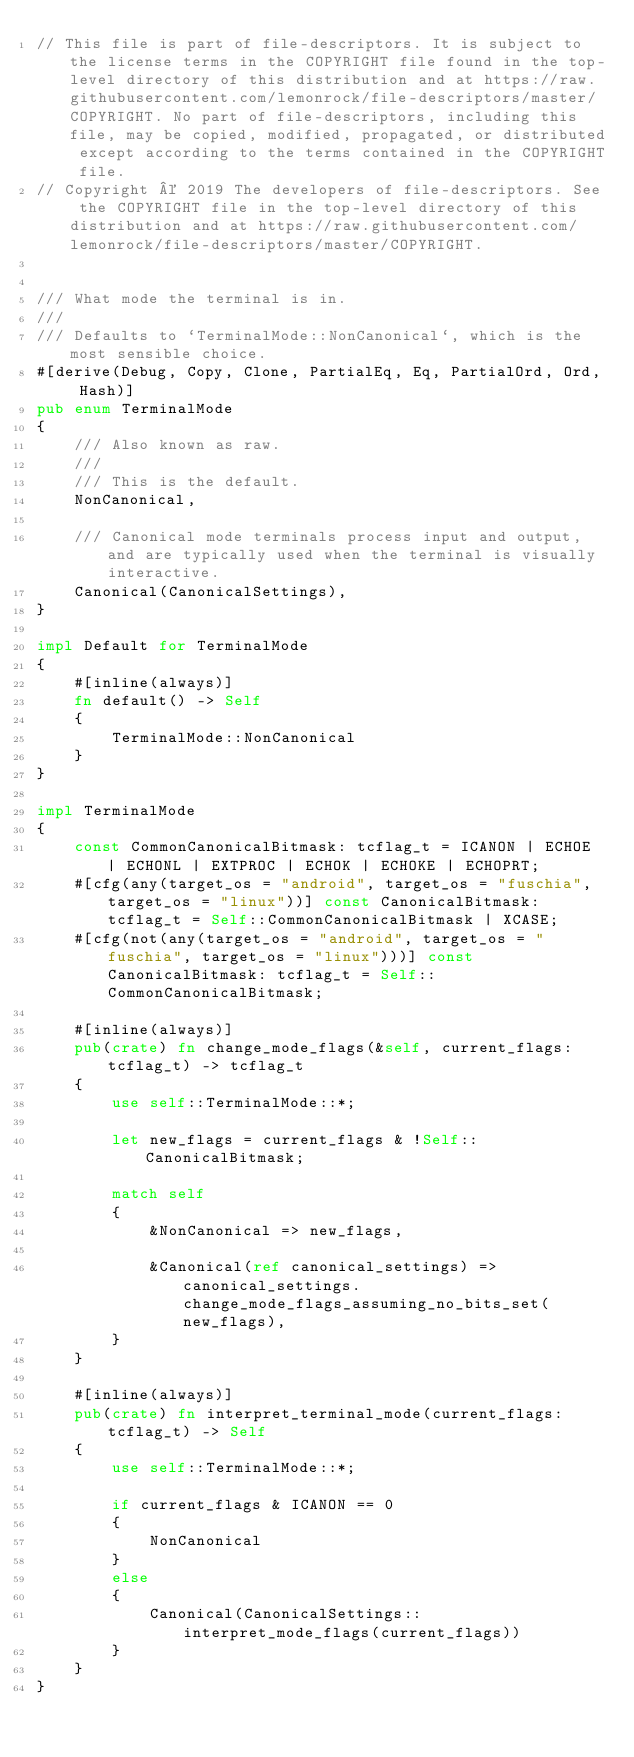<code> <loc_0><loc_0><loc_500><loc_500><_Rust_>// This file is part of file-descriptors. It is subject to the license terms in the COPYRIGHT file found in the top-level directory of this distribution and at https://raw.githubusercontent.com/lemonrock/file-descriptors/master/COPYRIGHT. No part of file-descriptors, including this file, may be copied, modified, propagated, or distributed except according to the terms contained in the COPYRIGHT file.
// Copyright © 2019 The developers of file-descriptors. See the COPYRIGHT file in the top-level directory of this distribution and at https://raw.githubusercontent.com/lemonrock/file-descriptors/master/COPYRIGHT.


/// What mode the terminal is in.
///
/// Defaults to `TerminalMode::NonCanonical`, which is the most sensible choice.
#[derive(Debug, Copy, Clone, PartialEq, Eq, PartialOrd, Ord, Hash)]
pub enum TerminalMode
{
	/// Also known as raw.
	///
	/// This is the default.
	NonCanonical,

	/// Canonical mode terminals process input and output, and are typically used when the terminal is visually interactive.
	Canonical(CanonicalSettings),
}

impl Default for TerminalMode
{
	#[inline(always)]
	fn default() -> Self
	{
		TerminalMode::NonCanonical
	}
}

impl TerminalMode
{
	const CommonCanonicalBitmask: tcflag_t = ICANON | ECHOE | ECHONL | EXTPROC | ECHOK | ECHOKE | ECHOPRT;
	#[cfg(any(target_os = "android", target_os = "fuschia", target_os = "linux"))] const CanonicalBitmask: tcflag_t = Self::CommonCanonicalBitmask | XCASE;
	#[cfg(not(any(target_os = "android", target_os = "fuschia", target_os = "linux")))] const CanonicalBitmask: tcflag_t = Self::CommonCanonicalBitmask;

	#[inline(always)]
	pub(crate) fn change_mode_flags(&self, current_flags: tcflag_t) -> tcflag_t
	{
		use self::TerminalMode::*;

		let new_flags = current_flags & !Self::CanonicalBitmask;

		match self
		{
			&NonCanonical => new_flags,

			&Canonical(ref canonical_settings) => canonical_settings.change_mode_flags_assuming_no_bits_set(new_flags),
		}
	}

	#[inline(always)]
	pub(crate) fn interpret_terminal_mode(current_flags: tcflag_t) -> Self
	{
		use self::TerminalMode::*;

		if current_flags & ICANON == 0
		{
			NonCanonical
		}
		else
		{
			Canonical(CanonicalSettings::interpret_mode_flags(current_flags))
		}
	}
}
</code> 